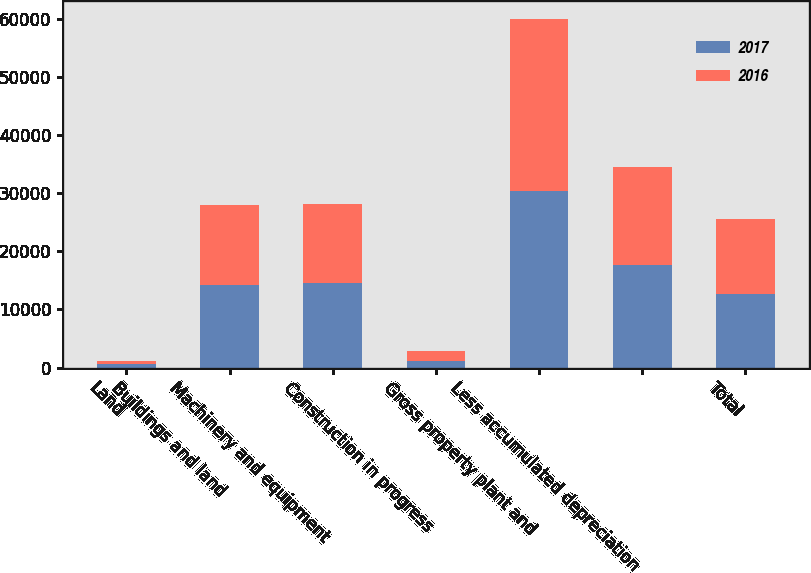Convert chart to OTSL. <chart><loc_0><loc_0><loc_500><loc_500><stacked_bar_chart><ecel><fcel>Land<fcel>Buildings and land<fcel>Machinery and equipment<fcel>Construction in progress<fcel>Gross property plant and<fcel>Less accumulated depreciation<fcel>Total<nl><fcel>2017<fcel>530<fcel>14125<fcel>14577<fcel>1081<fcel>30313<fcel>17641<fcel>12672<nl><fcel>2016<fcel>535<fcel>13796<fcel>13569<fcel>1790<fcel>29690<fcel>16883<fcel>12807<nl></chart> 